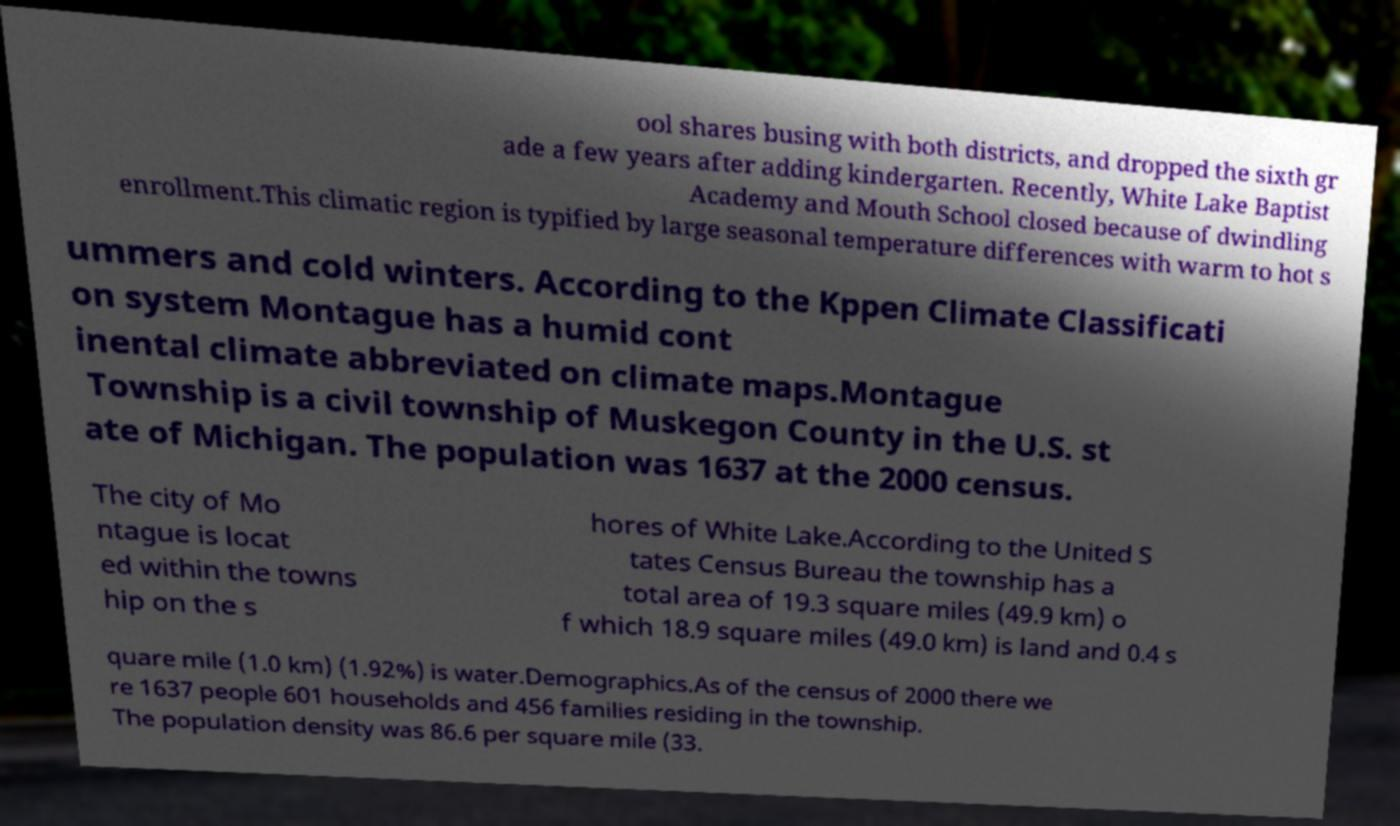There's text embedded in this image that I need extracted. Can you transcribe it verbatim? ool shares busing with both districts, and dropped the sixth gr ade a few years after adding kindergarten. Recently, White Lake Baptist Academy and Mouth School closed because of dwindling enrollment.This climatic region is typified by large seasonal temperature differences with warm to hot s ummers and cold winters. According to the Kppen Climate Classificati on system Montague has a humid cont inental climate abbreviated on climate maps.Montague Township is a civil township of Muskegon County in the U.S. st ate of Michigan. The population was 1637 at the 2000 census. The city of Mo ntague is locat ed within the towns hip on the s hores of White Lake.According to the United S tates Census Bureau the township has a total area of 19.3 square miles (49.9 km) o f which 18.9 square miles (49.0 km) is land and 0.4 s quare mile (1.0 km) (1.92%) is water.Demographics.As of the census of 2000 there we re 1637 people 601 households and 456 families residing in the township. The population density was 86.6 per square mile (33. 